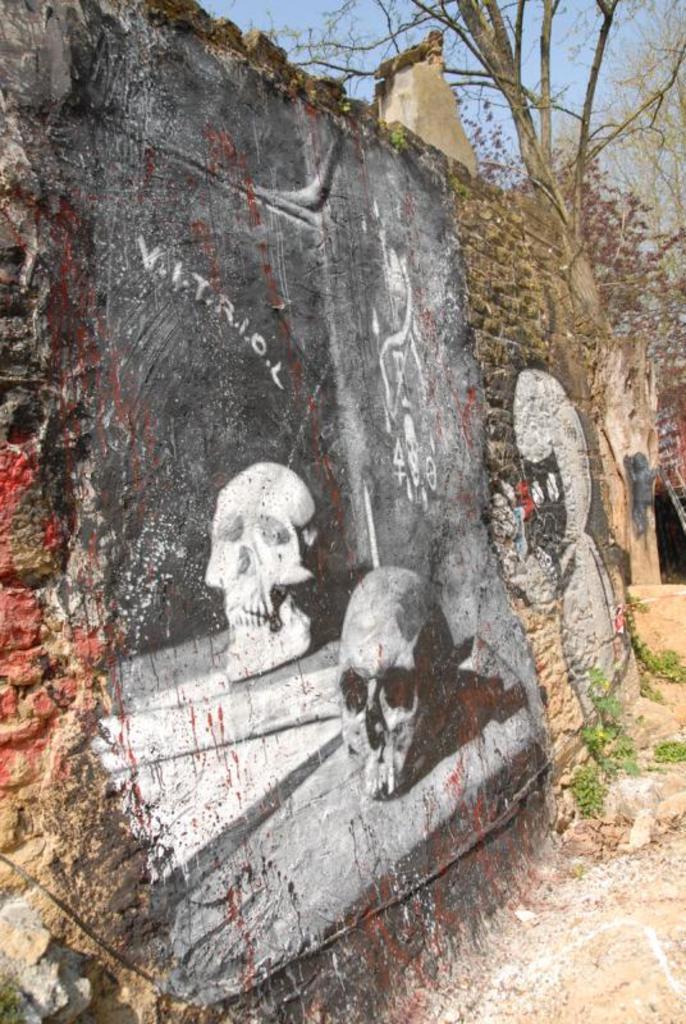Could you give a brief overview of what you see in this image? In the foreground of this image, there are paintings on the wall. On the right side, there are plants. On the top, there are trees and the sky. 